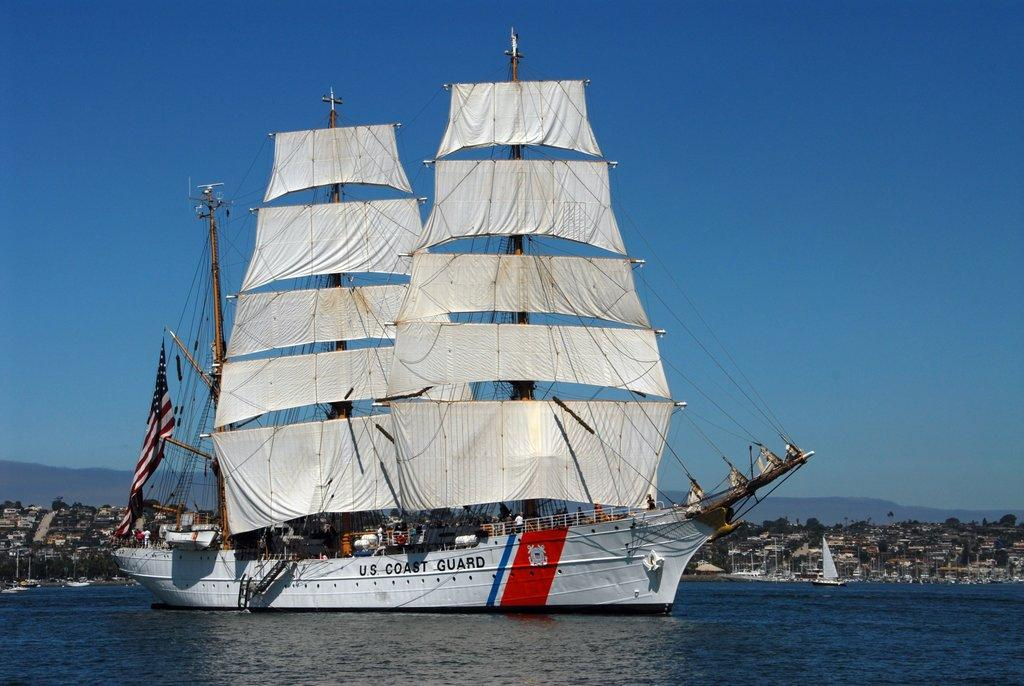What is the main subject in the center of the image? There are ships in the center of the image. Where are the ships located? The ships are on the water. What can be seen in the background of the image? There are buildings, trees, hills, and the sky visible in the background of the image. What type of egg is being distributed by the grandmother in the image? There is no egg or grandmother present in the image. 